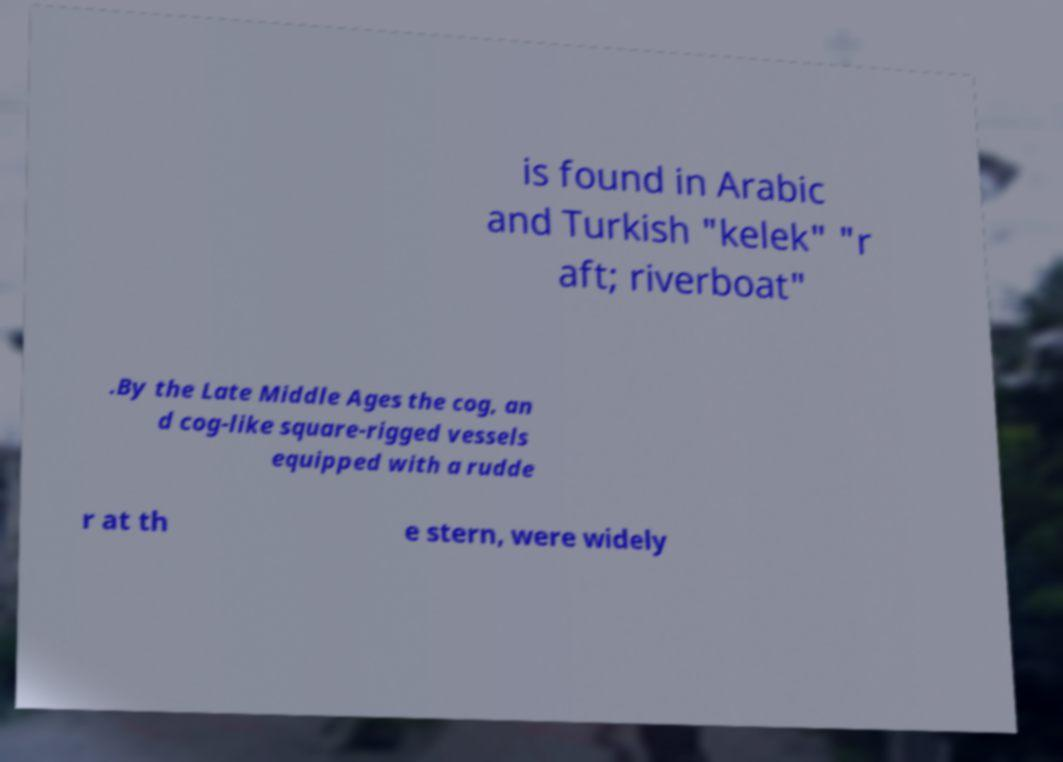Could you extract and type out the text from this image? is found in Arabic and Turkish "kelek" "r aft; riverboat" .By the Late Middle Ages the cog, an d cog-like square-rigged vessels equipped with a rudde r at th e stern, were widely 